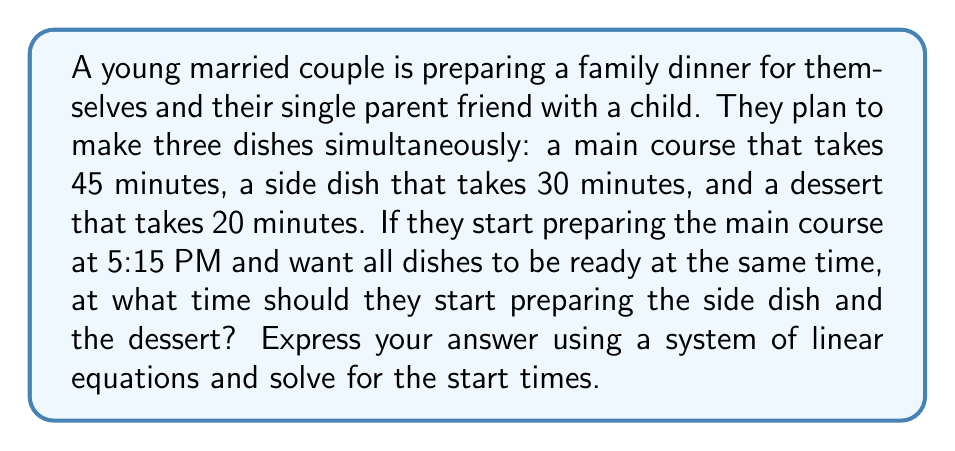Give your solution to this math problem. Let's approach this problem step by step using a system of linear equations:

1) Let's define our variables:
   $x$ = time (in minutes) after 5:15 PM to start the side dish
   $y$ = time (in minutes) after 5:15 PM to start the dessert

2) We know that all dishes should be ready at the same time. This means:
   - Main course: 45 minutes from start (5:15 PM)
   - Side dish: 30 minutes from its start time
   - Dessert: 20 minutes from its start time

3) We can set up two equations based on this information:
   $$45 = x + 30$$
   $$45 = y + 20$$

4) This gives us our system of linear equations:
   $$\begin{cases}
   x + 30 = 45 \\
   y + 20 = 45
   \end{cases}$$

5) Solving for $x$:
   $x + 30 = 45$
   $x = 45 - 30 = 15$

6) Solving for $y$:
   $y + 20 = 45$
   $y = 45 - 20 = 25$

7) Interpreting the results:
   - Side dish should be started 15 minutes after 5:15 PM, which is 5:30 PM
   - Dessert should be started 25 minutes after 5:15 PM, which is 5:40 PM
Answer: The side dish should be started at 5:30 PM, and the dessert should be started at 5:40 PM. This can be represented by the solution to the system of linear equations:

$$\begin{cases}
x = 15 \\
y = 25
\end{cases}$$

Where $x$ and $y$ represent the number of minutes after 5:15 PM to start the side dish and dessert, respectively. 